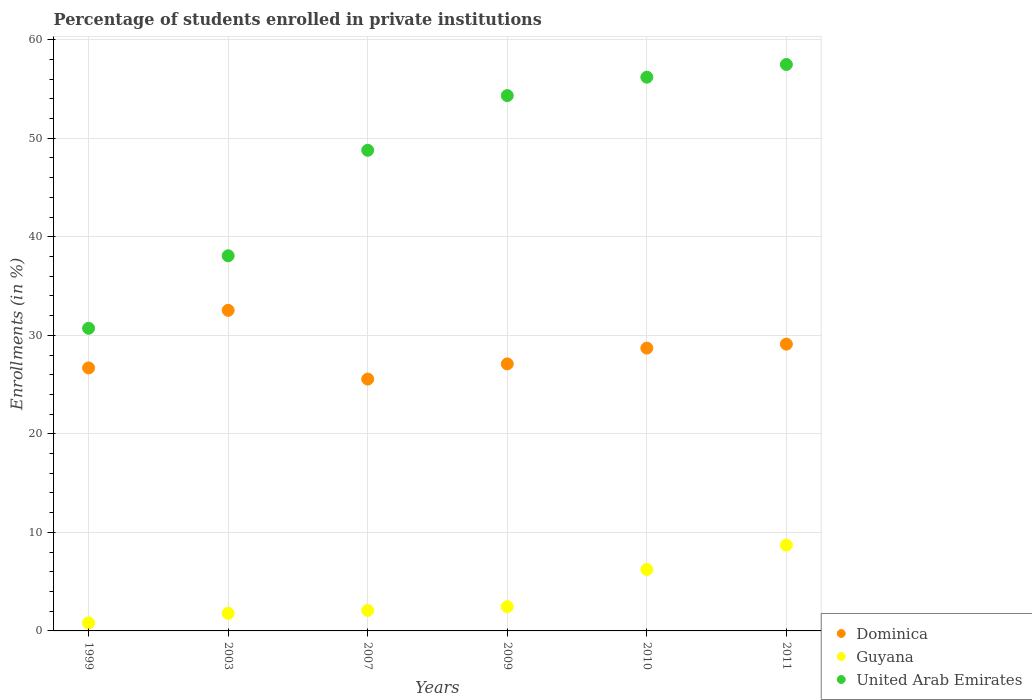Is the number of dotlines equal to the number of legend labels?
Offer a very short reply. Yes. What is the percentage of trained teachers in Dominica in 2010?
Give a very brief answer. 28.7. Across all years, what is the maximum percentage of trained teachers in Guyana?
Your answer should be compact. 8.71. Across all years, what is the minimum percentage of trained teachers in United Arab Emirates?
Ensure brevity in your answer.  30.71. In which year was the percentage of trained teachers in United Arab Emirates minimum?
Your response must be concise. 1999. What is the total percentage of trained teachers in United Arab Emirates in the graph?
Your answer should be very brief. 285.57. What is the difference between the percentage of trained teachers in United Arab Emirates in 2003 and that in 2009?
Give a very brief answer. -16.26. What is the difference between the percentage of trained teachers in Guyana in 2003 and the percentage of trained teachers in Dominica in 2009?
Keep it short and to the point. -25.31. What is the average percentage of trained teachers in United Arab Emirates per year?
Provide a succinct answer. 47.6. In the year 1999, what is the difference between the percentage of trained teachers in United Arab Emirates and percentage of trained teachers in Guyana?
Your answer should be very brief. 29.9. In how many years, is the percentage of trained teachers in United Arab Emirates greater than 22 %?
Provide a short and direct response. 6. What is the ratio of the percentage of trained teachers in United Arab Emirates in 1999 to that in 2003?
Keep it short and to the point. 0.81. Is the difference between the percentage of trained teachers in United Arab Emirates in 2003 and 2007 greater than the difference between the percentage of trained teachers in Guyana in 2003 and 2007?
Ensure brevity in your answer.  No. What is the difference between the highest and the second highest percentage of trained teachers in Guyana?
Offer a terse response. 2.47. What is the difference between the highest and the lowest percentage of trained teachers in Guyana?
Your answer should be compact. 7.89. In how many years, is the percentage of trained teachers in United Arab Emirates greater than the average percentage of trained teachers in United Arab Emirates taken over all years?
Offer a terse response. 4. Is the sum of the percentage of trained teachers in United Arab Emirates in 2003 and 2009 greater than the maximum percentage of trained teachers in Dominica across all years?
Your response must be concise. Yes. Is the percentage of trained teachers in United Arab Emirates strictly greater than the percentage of trained teachers in Guyana over the years?
Provide a succinct answer. Yes. How many dotlines are there?
Your answer should be compact. 3. How many years are there in the graph?
Provide a succinct answer. 6. Are the values on the major ticks of Y-axis written in scientific E-notation?
Ensure brevity in your answer.  No. Does the graph contain grids?
Provide a short and direct response. Yes. How are the legend labels stacked?
Keep it short and to the point. Vertical. What is the title of the graph?
Provide a succinct answer. Percentage of students enrolled in private institutions. What is the label or title of the Y-axis?
Your response must be concise. Enrollments (in %). What is the Enrollments (in %) in Dominica in 1999?
Provide a succinct answer. 26.69. What is the Enrollments (in %) of Guyana in 1999?
Your response must be concise. 0.81. What is the Enrollments (in %) in United Arab Emirates in 1999?
Your answer should be very brief. 30.71. What is the Enrollments (in %) in Dominica in 2003?
Offer a terse response. 32.53. What is the Enrollments (in %) in Guyana in 2003?
Your answer should be very brief. 1.79. What is the Enrollments (in %) of United Arab Emirates in 2003?
Keep it short and to the point. 38.07. What is the Enrollments (in %) in Dominica in 2007?
Offer a terse response. 25.56. What is the Enrollments (in %) of Guyana in 2007?
Offer a terse response. 2.07. What is the Enrollments (in %) in United Arab Emirates in 2007?
Your response must be concise. 48.78. What is the Enrollments (in %) of Dominica in 2009?
Provide a succinct answer. 27.1. What is the Enrollments (in %) in Guyana in 2009?
Give a very brief answer. 2.46. What is the Enrollments (in %) of United Arab Emirates in 2009?
Provide a succinct answer. 54.33. What is the Enrollments (in %) in Dominica in 2010?
Your response must be concise. 28.7. What is the Enrollments (in %) in Guyana in 2010?
Offer a very short reply. 6.23. What is the Enrollments (in %) in United Arab Emirates in 2010?
Provide a short and direct response. 56.2. What is the Enrollments (in %) in Dominica in 2011?
Keep it short and to the point. 29.11. What is the Enrollments (in %) of Guyana in 2011?
Your answer should be compact. 8.71. What is the Enrollments (in %) in United Arab Emirates in 2011?
Make the answer very short. 57.49. Across all years, what is the maximum Enrollments (in %) in Dominica?
Keep it short and to the point. 32.53. Across all years, what is the maximum Enrollments (in %) in Guyana?
Ensure brevity in your answer.  8.71. Across all years, what is the maximum Enrollments (in %) of United Arab Emirates?
Offer a terse response. 57.49. Across all years, what is the minimum Enrollments (in %) of Dominica?
Keep it short and to the point. 25.56. Across all years, what is the minimum Enrollments (in %) of Guyana?
Provide a succinct answer. 0.81. Across all years, what is the minimum Enrollments (in %) of United Arab Emirates?
Provide a succinct answer. 30.71. What is the total Enrollments (in %) of Dominica in the graph?
Ensure brevity in your answer.  169.69. What is the total Enrollments (in %) of Guyana in the graph?
Offer a very short reply. 22.08. What is the total Enrollments (in %) in United Arab Emirates in the graph?
Ensure brevity in your answer.  285.57. What is the difference between the Enrollments (in %) in Dominica in 1999 and that in 2003?
Provide a short and direct response. -5.84. What is the difference between the Enrollments (in %) in Guyana in 1999 and that in 2003?
Your answer should be very brief. -0.97. What is the difference between the Enrollments (in %) of United Arab Emirates in 1999 and that in 2003?
Provide a short and direct response. -7.36. What is the difference between the Enrollments (in %) of Dominica in 1999 and that in 2007?
Keep it short and to the point. 1.13. What is the difference between the Enrollments (in %) in Guyana in 1999 and that in 2007?
Your response must be concise. -1.26. What is the difference between the Enrollments (in %) of United Arab Emirates in 1999 and that in 2007?
Give a very brief answer. -18.07. What is the difference between the Enrollments (in %) of Dominica in 1999 and that in 2009?
Provide a short and direct response. -0.41. What is the difference between the Enrollments (in %) of Guyana in 1999 and that in 2009?
Your answer should be very brief. -1.65. What is the difference between the Enrollments (in %) of United Arab Emirates in 1999 and that in 2009?
Your answer should be compact. -23.62. What is the difference between the Enrollments (in %) of Dominica in 1999 and that in 2010?
Give a very brief answer. -2.01. What is the difference between the Enrollments (in %) in Guyana in 1999 and that in 2010?
Your response must be concise. -5.42. What is the difference between the Enrollments (in %) of United Arab Emirates in 1999 and that in 2010?
Your response must be concise. -25.48. What is the difference between the Enrollments (in %) of Dominica in 1999 and that in 2011?
Provide a succinct answer. -2.42. What is the difference between the Enrollments (in %) of Guyana in 1999 and that in 2011?
Offer a terse response. -7.89. What is the difference between the Enrollments (in %) of United Arab Emirates in 1999 and that in 2011?
Make the answer very short. -26.77. What is the difference between the Enrollments (in %) in Dominica in 2003 and that in 2007?
Ensure brevity in your answer.  6.98. What is the difference between the Enrollments (in %) in Guyana in 2003 and that in 2007?
Offer a very short reply. -0.29. What is the difference between the Enrollments (in %) of United Arab Emirates in 2003 and that in 2007?
Your answer should be very brief. -10.71. What is the difference between the Enrollments (in %) of Dominica in 2003 and that in 2009?
Give a very brief answer. 5.43. What is the difference between the Enrollments (in %) in Guyana in 2003 and that in 2009?
Your response must be concise. -0.68. What is the difference between the Enrollments (in %) of United Arab Emirates in 2003 and that in 2009?
Offer a terse response. -16.26. What is the difference between the Enrollments (in %) of Dominica in 2003 and that in 2010?
Provide a short and direct response. 3.83. What is the difference between the Enrollments (in %) of Guyana in 2003 and that in 2010?
Offer a very short reply. -4.45. What is the difference between the Enrollments (in %) of United Arab Emirates in 2003 and that in 2010?
Keep it short and to the point. -18.13. What is the difference between the Enrollments (in %) in Dominica in 2003 and that in 2011?
Your response must be concise. 3.43. What is the difference between the Enrollments (in %) of Guyana in 2003 and that in 2011?
Keep it short and to the point. -6.92. What is the difference between the Enrollments (in %) in United Arab Emirates in 2003 and that in 2011?
Offer a terse response. -19.41. What is the difference between the Enrollments (in %) of Dominica in 2007 and that in 2009?
Your answer should be very brief. -1.54. What is the difference between the Enrollments (in %) of Guyana in 2007 and that in 2009?
Give a very brief answer. -0.39. What is the difference between the Enrollments (in %) of United Arab Emirates in 2007 and that in 2009?
Your answer should be compact. -5.55. What is the difference between the Enrollments (in %) of Dominica in 2007 and that in 2010?
Your answer should be very brief. -3.14. What is the difference between the Enrollments (in %) of Guyana in 2007 and that in 2010?
Ensure brevity in your answer.  -4.16. What is the difference between the Enrollments (in %) in United Arab Emirates in 2007 and that in 2010?
Provide a short and direct response. -7.42. What is the difference between the Enrollments (in %) of Dominica in 2007 and that in 2011?
Your answer should be very brief. -3.55. What is the difference between the Enrollments (in %) in Guyana in 2007 and that in 2011?
Offer a terse response. -6.63. What is the difference between the Enrollments (in %) of United Arab Emirates in 2007 and that in 2011?
Provide a short and direct response. -8.71. What is the difference between the Enrollments (in %) of Dominica in 2009 and that in 2010?
Provide a succinct answer. -1.6. What is the difference between the Enrollments (in %) in Guyana in 2009 and that in 2010?
Make the answer very short. -3.77. What is the difference between the Enrollments (in %) in United Arab Emirates in 2009 and that in 2010?
Provide a succinct answer. -1.87. What is the difference between the Enrollments (in %) of Dominica in 2009 and that in 2011?
Ensure brevity in your answer.  -2.01. What is the difference between the Enrollments (in %) of Guyana in 2009 and that in 2011?
Your answer should be very brief. -6.24. What is the difference between the Enrollments (in %) in United Arab Emirates in 2009 and that in 2011?
Offer a very short reply. -3.16. What is the difference between the Enrollments (in %) of Dominica in 2010 and that in 2011?
Offer a terse response. -0.4. What is the difference between the Enrollments (in %) of Guyana in 2010 and that in 2011?
Your answer should be very brief. -2.47. What is the difference between the Enrollments (in %) in United Arab Emirates in 2010 and that in 2011?
Keep it short and to the point. -1.29. What is the difference between the Enrollments (in %) in Dominica in 1999 and the Enrollments (in %) in Guyana in 2003?
Keep it short and to the point. 24.9. What is the difference between the Enrollments (in %) of Dominica in 1999 and the Enrollments (in %) of United Arab Emirates in 2003?
Offer a very short reply. -11.38. What is the difference between the Enrollments (in %) of Guyana in 1999 and the Enrollments (in %) of United Arab Emirates in 2003?
Offer a very short reply. -37.26. What is the difference between the Enrollments (in %) of Dominica in 1999 and the Enrollments (in %) of Guyana in 2007?
Offer a terse response. 24.62. What is the difference between the Enrollments (in %) of Dominica in 1999 and the Enrollments (in %) of United Arab Emirates in 2007?
Provide a succinct answer. -22.09. What is the difference between the Enrollments (in %) of Guyana in 1999 and the Enrollments (in %) of United Arab Emirates in 2007?
Provide a succinct answer. -47.97. What is the difference between the Enrollments (in %) of Dominica in 1999 and the Enrollments (in %) of Guyana in 2009?
Keep it short and to the point. 24.23. What is the difference between the Enrollments (in %) of Dominica in 1999 and the Enrollments (in %) of United Arab Emirates in 2009?
Offer a terse response. -27.64. What is the difference between the Enrollments (in %) of Guyana in 1999 and the Enrollments (in %) of United Arab Emirates in 2009?
Ensure brevity in your answer.  -53.52. What is the difference between the Enrollments (in %) of Dominica in 1999 and the Enrollments (in %) of Guyana in 2010?
Offer a terse response. 20.46. What is the difference between the Enrollments (in %) in Dominica in 1999 and the Enrollments (in %) in United Arab Emirates in 2010?
Give a very brief answer. -29.51. What is the difference between the Enrollments (in %) in Guyana in 1999 and the Enrollments (in %) in United Arab Emirates in 2010?
Your answer should be compact. -55.38. What is the difference between the Enrollments (in %) of Dominica in 1999 and the Enrollments (in %) of Guyana in 2011?
Make the answer very short. 17.99. What is the difference between the Enrollments (in %) in Dominica in 1999 and the Enrollments (in %) in United Arab Emirates in 2011?
Make the answer very short. -30.79. What is the difference between the Enrollments (in %) of Guyana in 1999 and the Enrollments (in %) of United Arab Emirates in 2011?
Offer a very short reply. -56.67. What is the difference between the Enrollments (in %) of Dominica in 2003 and the Enrollments (in %) of Guyana in 2007?
Keep it short and to the point. 30.46. What is the difference between the Enrollments (in %) in Dominica in 2003 and the Enrollments (in %) in United Arab Emirates in 2007?
Ensure brevity in your answer.  -16.24. What is the difference between the Enrollments (in %) in Guyana in 2003 and the Enrollments (in %) in United Arab Emirates in 2007?
Keep it short and to the point. -46.99. What is the difference between the Enrollments (in %) of Dominica in 2003 and the Enrollments (in %) of Guyana in 2009?
Your answer should be very brief. 30.07. What is the difference between the Enrollments (in %) in Dominica in 2003 and the Enrollments (in %) in United Arab Emirates in 2009?
Your answer should be very brief. -21.79. What is the difference between the Enrollments (in %) in Guyana in 2003 and the Enrollments (in %) in United Arab Emirates in 2009?
Provide a succinct answer. -52.54. What is the difference between the Enrollments (in %) in Dominica in 2003 and the Enrollments (in %) in Guyana in 2010?
Provide a succinct answer. 26.3. What is the difference between the Enrollments (in %) in Dominica in 2003 and the Enrollments (in %) in United Arab Emirates in 2010?
Your response must be concise. -23.66. What is the difference between the Enrollments (in %) in Guyana in 2003 and the Enrollments (in %) in United Arab Emirates in 2010?
Your answer should be very brief. -54.41. What is the difference between the Enrollments (in %) of Dominica in 2003 and the Enrollments (in %) of Guyana in 2011?
Your response must be concise. 23.83. What is the difference between the Enrollments (in %) of Dominica in 2003 and the Enrollments (in %) of United Arab Emirates in 2011?
Your answer should be very brief. -24.95. What is the difference between the Enrollments (in %) of Guyana in 2003 and the Enrollments (in %) of United Arab Emirates in 2011?
Offer a very short reply. -55.7. What is the difference between the Enrollments (in %) in Dominica in 2007 and the Enrollments (in %) in Guyana in 2009?
Offer a very short reply. 23.09. What is the difference between the Enrollments (in %) in Dominica in 2007 and the Enrollments (in %) in United Arab Emirates in 2009?
Give a very brief answer. -28.77. What is the difference between the Enrollments (in %) in Guyana in 2007 and the Enrollments (in %) in United Arab Emirates in 2009?
Provide a succinct answer. -52.25. What is the difference between the Enrollments (in %) of Dominica in 2007 and the Enrollments (in %) of Guyana in 2010?
Offer a very short reply. 19.32. What is the difference between the Enrollments (in %) of Dominica in 2007 and the Enrollments (in %) of United Arab Emirates in 2010?
Your answer should be compact. -30.64. What is the difference between the Enrollments (in %) in Guyana in 2007 and the Enrollments (in %) in United Arab Emirates in 2010?
Give a very brief answer. -54.12. What is the difference between the Enrollments (in %) of Dominica in 2007 and the Enrollments (in %) of Guyana in 2011?
Provide a succinct answer. 16.85. What is the difference between the Enrollments (in %) in Dominica in 2007 and the Enrollments (in %) in United Arab Emirates in 2011?
Provide a succinct answer. -31.93. What is the difference between the Enrollments (in %) in Guyana in 2007 and the Enrollments (in %) in United Arab Emirates in 2011?
Offer a terse response. -55.41. What is the difference between the Enrollments (in %) of Dominica in 2009 and the Enrollments (in %) of Guyana in 2010?
Offer a terse response. 20.87. What is the difference between the Enrollments (in %) in Dominica in 2009 and the Enrollments (in %) in United Arab Emirates in 2010?
Give a very brief answer. -29.1. What is the difference between the Enrollments (in %) of Guyana in 2009 and the Enrollments (in %) of United Arab Emirates in 2010?
Your answer should be very brief. -53.73. What is the difference between the Enrollments (in %) in Dominica in 2009 and the Enrollments (in %) in Guyana in 2011?
Your answer should be compact. 18.39. What is the difference between the Enrollments (in %) of Dominica in 2009 and the Enrollments (in %) of United Arab Emirates in 2011?
Your answer should be very brief. -30.39. What is the difference between the Enrollments (in %) of Guyana in 2009 and the Enrollments (in %) of United Arab Emirates in 2011?
Ensure brevity in your answer.  -55.02. What is the difference between the Enrollments (in %) in Dominica in 2010 and the Enrollments (in %) in Guyana in 2011?
Provide a short and direct response. 20. What is the difference between the Enrollments (in %) of Dominica in 2010 and the Enrollments (in %) of United Arab Emirates in 2011?
Your answer should be very brief. -28.78. What is the difference between the Enrollments (in %) in Guyana in 2010 and the Enrollments (in %) in United Arab Emirates in 2011?
Your answer should be compact. -51.25. What is the average Enrollments (in %) in Dominica per year?
Your answer should be compact. 28.28. What is the average Enrollments (in %) of Guyana per year?
Provide a short and direct response. 3.68. What is the average Enrollments (in %) in United Arab Emirates per year?
Offer a terse response. 47.6. In the year 1999, what is the difference between the Enrollments (in %) of Dominica and Enrollments (in %) of Guyana?
Make the answer very short. 25.88. In the year 1999, what is the difference between the Enrollments (in %) of Dominica and Enrollments (in %) of United Arab Emirates?
Offer a terse response. -4.02. In the year 1999, what is the difference between the Enrollments (in %) in Guyana and Enrollments (in %) in United Arab Emirates?
Provide a short and direct response. -29.9. In the year 2003, what is the difference between the Enrollments (in %) of Dominica and Enrollments (in %) of Guyana?
Your answer should be very brief. 30.75. In the year 2003, what is the difference between the Enrollments (in %) of Dominica and Enrollments (in %) of United Arab Emirates?
Keep it short and to the point. -5.54. In the year 2003, what is the difference between the Enrollments (in %) in Guyana and Enrollments (in %) in United Arab Emirates?
Offer a terse response. -36.28. In the year 2007, what is the difference between the Enrollments (in %) of Dominica and Enrollments (in %) of Guyana?
Ensure brevity in your answer.  23.48. In the year 2007, what is the difference between the Enrollments (in %) in Dominica and Enrollments (in %) in United Arab Emirates?
Your response must be concise. -23.22. In the year 2007, what is the difference between the Enrollments (in %) of Guyana and Enrollments (in %) of United Arab Emirates?
Your answer should be compact. -46.7. In the year 2009, what is the difference between the Enrollments (in %) in Dominica and Enrollments (in %) in Guyana?
Keep it short and to the point. 24.64. In the year 2009, what is the difference between the Enrollments (in %) of Dominica and Enrollments (in %) of United Arab Emirates?
Make the answer very short. -27.23. In the year 2009, what is the difference between the Enrollments (in %) in Guyana and Enrollments (in %) in United Arab Emirates?
Your answer should be very brief. -51.87. In the year 2010, what is the difference between the Enrollments (in %) in Dominica and Enrollments (in %) in Guyana?
Provide a short and direct response. 22.47. In the year 2010, what is the difference between the Enrollments (in %) in Dominica and Enrollments (in %) in United Arab Emirates?
Your answer should be compact. -27.5. In the year 2010, what is the difference between the Enrollments (in %) of Guyana and Enrollments (in %) of United Arab Emirates?
Provide a succinct answer. -49.96. In the year 2011, what is the difference between the Enrollments (in %) in Dominica and Enrollments (in %) in Guyana?
Offer a very short reply. 20.4. In the year 2011, what is the difference between the Enrollments (in %) in Dominica and Enrollments (in %) in United Arab Emirates?
Provide a short and direct response. -28.38. In the year 2011, what is the difference between the Enrollments (in %) of Guyana and Enrollments (in %) of United Arab Emirates?
Your answer should be very brief. -48.78. What is the ratio of the Enrollments (in %) of Dominica in 1999 to that in 2003?
Offer a terse response. 0.82. What is the ratio of the Enrollments (in %) of Guyana in 1999 to that in 2003?
Your answer should be very brief. 0.45. What is the ratio of the Enrollments (in %) in United Arab Emirates in 1999 to that in 2003?
Give a very brief answer. 0.81. What is the ratio of the Enrollments (in %) in Dominica in 1999 to that in 2007?
Offer a very short reply. 1.04. What is the ratio of the Enrollments (in %) in Guyana in 1999 to that in 2007?
Keep it short and to the point. 0.39. What is the ratio of the Enrollments (in %) of United Arab Emirates in 1999 to that in 2007?
Offer a very short reply. 0.63. What is the ratio of the Enrollments (in %) in Dominica in 1999 to that in 2009?
Your answer should be compact. 0.98. What is the ratio of the Enrollments (in %) of Guyana in 1999 to that in 2009?
Offer a very short reply. 0.33. What is the ratio of the Enrollments (in %) of United Arab Emirates in 1999 to that in 2009?
Provide a short and direct response. 0.57. What is the ratio of the Enrollments (in %) of Dominica in 1999 to that in 2010?
Provide a succinct answer. 0.93. What is the ratio of the Enrollments (in %) of Guyana in 1999 to that in 2010?
Provide a succinct answer. 0.13. What is the ratio of the Enrollments (in %) in United Arab Emirates in 1999 to that in 2010?
Your response must be concise. 0.55. What is the ratio of the Enrollments (in %) of Dominica in 1999 to that in 2011?
Ensure brevity in your answer.  0.92. What is the ratio of the Enrollments (in %) of Guyana in 1999 to that in 2011?
Your answer should be very brief. 0.09. What is the ratio of the Enrollments (in %) of United Arab Emirates in 1999 to that in 2011?
Make the answer very short. 0.53. What is the ratio of the Enrollments (in %) in Dominica in 2003 to that in 2007?
Your response must be concise. 1.27. What is the ratio of the Enrollments (in %) in Guyana in 2003 to that in 2007?
Your answer should be compact. 0.86. What is the ratio of the Enrollments (in %) of United Arab Emirates in 2003 to that in 2007?
Your answer should be compact. 0.78. What is the ratio of the Enrollments (in %) of Dominica in 2003 to that in 2009?
Your answer should be compact. 1.2. What is the ratio of the Enrollments (in %) of Guyana in 2003 to that in 2009?
Provide a short and direct response. 0.73. What is the ratio of the Enrollments (in %) of United Arab Emirates in 2003 to that in 2009?
Make the answer very short. 0.7. What is the ratio of the Enrollments (in %) in Dominica in 2003 to that in 2010?
Ensure brevity in your answer.  1.13. What is the ratio of the Enrollments (in %) of Guyana in 2003 to that in 2010?
Provide a succinct answer. 0.29. What is the ratio of the Enrollments (in %) in United Arab Emirates in 2003 to that in 2010?
Your answer should be very brief. 0.68. What is the ratio of the Enrollments (in %) of Dominica in 2003 to that in 2011?
Provide a short and direct response. 1.12. What is the ratio of the Enrollments (in %) of Guyana in 2003 to that in 2011?
Your response must be concise. 0.21. What is the ratio of the Enrollments (in %) of United Arab Emirates in 2003 to that in 2011?
Give a very brief answer. 0.66. What is the ratio of the Enrollments (in %) of Dominica in 2007 to that in 2009?
Your response must be concise. 0.94. What is the ratio of the Enrollments (in %) of Guyana in 2007 to that in 2009?
Your answer should be very brief. 0.84. What is the ratio of the Enrollments (in %) of United Arab Emirates in 2007 to that in 2009?
Offer a very short reply. 0.9. What is the ratio of the Enrollments (in %) in Dominica in 2007 to that in 2010?
Make the answer very short. 0.89. What is the ratio of the Enrollments (in %) in Guyana in 2007 to that in 2010?
Ensure brevity in your answer.  0.33. What is the ratio of the Enrollments (in %) of United Arab Emirates in 2007 to that in 2010?
Provide a succinct answer. 0.87. What is the ratio of the Enrollments (in %) in Dominica in 2007 to that in 2011?
Make the answer very short. 0.88. What is the ratio of the Enrollments (in %) of Guyana in 2007 to that in 2011?
Offer a very short reply. 0.24. What is the ratio of the Enrollments (in %) in United Arab Emirates in 2007 to that in 2011?
Your response must be concise. 0.85. What is the ratio of the Enrollments (in %) of Dominica in 2009 to that in 2010?
Provide a succinct answer. 0.94. What is the ratio of the Enrollments (in %) in Guyana in 2009 to that in 2010?
Offer a terse response. 0.4. What is the ratio of the Enrollments (in %) of United Arab Emirates in 2009 to that in 2010?
Make the answer very short. 0.97. What is the ratio of the Enrollments (in %) of Dominica in 2009 to that in 2011?
Give a very brief answer. 0.93. What is the ratio of the Enrollments (in %) of Guyana in 2009 to that in 2011?
Your answer should be compact. 0.28. What is the ratio of the Enrollments (in %) of United Arab Emirates in 2009 to that in 2011?
Provide a succinct answer. 0.95. What is the ratio of the Enrollments (in %) in Dominica in 2010 to that in 2011?
Give a very brief answer. 0.99. What is the ratio of the Enrollments (in %) in Guyana in 2010 to that in 2011?
Offer a very short reply. 0.72. What is the ratio of the Enrollments (in %) of United Arab Emirates in 2010 to that in 2011?
Your answer should be compact. 0.98. What is the difference between the highest and the second highest Enrollments (in %) in Dominica?
Offer a terse response. 3.43. What is the difference between the highest and the second highest Enrollments (in %) of Guyana?
Your answer should be compact. 2.47. What is the difference between the highest and the second highest Enrollments (in %) of United Arab Emirates?
Give a very brief answer. 1.29. What is the difference between the highest and the lowest Enrollments (in %) of Dominica?
Give a very brief answer. 6.98. What is the difference between the highest and the lowest Enrollments (in %) of Guyana?
Offer a very short reply. 7.89. What is the difference between the highest and the lowest Enrollments (in %) of United Arab Emirates?
Provide a short and direct response. 26.77. 